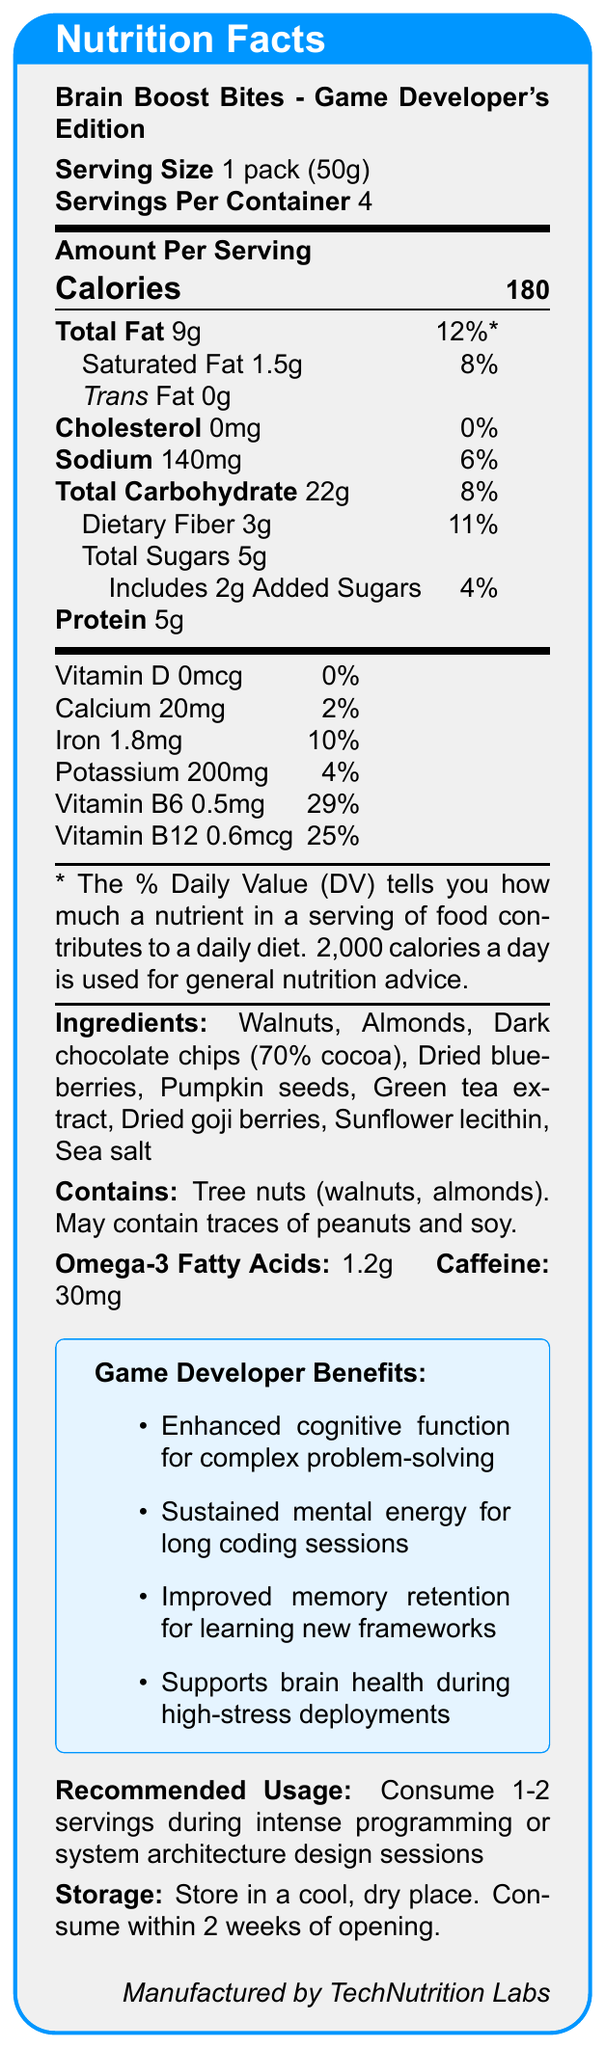what is the serving size for Brain Boost Bites - Game Developer's Edition? According to the nutrition facts label, the serving size is explicitly stated as 1 pack (50g).
Answer: 1 pack (50g) how many servings are there per container? The document lists that there are 4 servings per container.
Answer: 4 how many calories are there per serving? The label shows that each serving contains 180 calories.
Answer: 180 what is the total fat content per serving and its daily value percentage? The total fat content per serving is 9g, which is 12% of the daily value.
Answer: 9g, 12% does the product contain any cholesterol? According to the nutrition facts, the product has 0mg of cholesterol, which is 0% of the daily value.
Answer: No how much protein does one serving provide? The nutrition label indicates that one serving provides 5g of protein.
Answer: 5g which vitamins are predominantly present in Brain Boost Bites, and what percentages of the daily value do they provide? A. Vitamin C and Vitamin D, B. Vitamin B6 and Vitamin B12, C. Vitamin A and Vitamin E The predominant vitamins are Vitamin B6 (29% DV) and Vitamin B12 (25% DV).
Answer: B what is the amount of sodium per serving? A. 140mg B. 200mg C. 100mg D. 50mg The document specifies that each serving contains 140mg of sodium.
Answer: A does Brain Boost Bites contain trans fat? The nutrition facts label lists trans fat as 0g per serving.
Answer: No is the product suitable for someone with a tree nut allergy? The allergen information states that it contains tree nuts (walnuts, almonds) and may contain traces of peanuts and soy.
Answer: No summarize the nutritional benefits targeted towards game developers. The document highlights four main benefits for game developers: enhanced cognitive function for problem-solving, sustained mental energy for coding sessions, improved memory retention for learning new frameworks, and support for brain health during high-stress deployments.
Answer: Enhanced cognitive function, sustained mental energy, improved memory retention, supports brain health how much caffeine is included in one serving and what ingredient is it derived from? The document specifies that each serving contains 30mg of caffeine, derived from green tea extract.
Answer: 30mg, Green tea extract which ingredient contributes to the product's high omega-3 fatty acids content? Walnuts are known for being a rich source of omega-3 fatty acids and are listed as one of the ingredients.
Answer: Walnuts is the product manufactured by TechNutrition Labs? The label indicates that the product is manufactured by TechNutrition Labs.
Answer: Yes how should the product be stored? The storage instructions advise to store in a cool, dry place and mention to consume within 2 weeks of opening.
Answer: In a cool, dry place, consume within 2 weeks of opening how much added sugar is in a serving of Brain Boost Bites? The amount of added sugars per serving is listed as 2g in the nutrition information.
Answer: 2g what are the recommended usage conditions for this product? The recommended usage is to consume 1-2 servings during intense programming or system architecture design sessions.
Answer: During intense programming or system architecture design sessions does Brain Boost Bites contain calcium, and if so, what is the amount and daily value percentage? The nutrition label indicates that each serving contains 20mg of calcium, which is 2% of the daily value.
Answer: Yes, 20mg, 2% what does the vitamin D content of the product amount to? The product contains 0mcg of vitamin D which amounts to 0% of the daily value.
Answer: 0mcg, 0% provide a brief description of the company that manufactures Brain Boost Bites. The label indicates that Brain Boost Bites is manufactured by TechNutrition Labs.
Answer: TechNutrition Labs are there any traces of peanuts or soy in this product? The allergen information states that the product may contain traces of peanuts and soy.
Answer: Yes, may contain traces what is not specified about the type of dark chocolate in the ingredients list? The ingredients list dark chocolate chips (70% cocoa) but does not specify the source of the cocoa beans.
Answer: Source of cocoa 